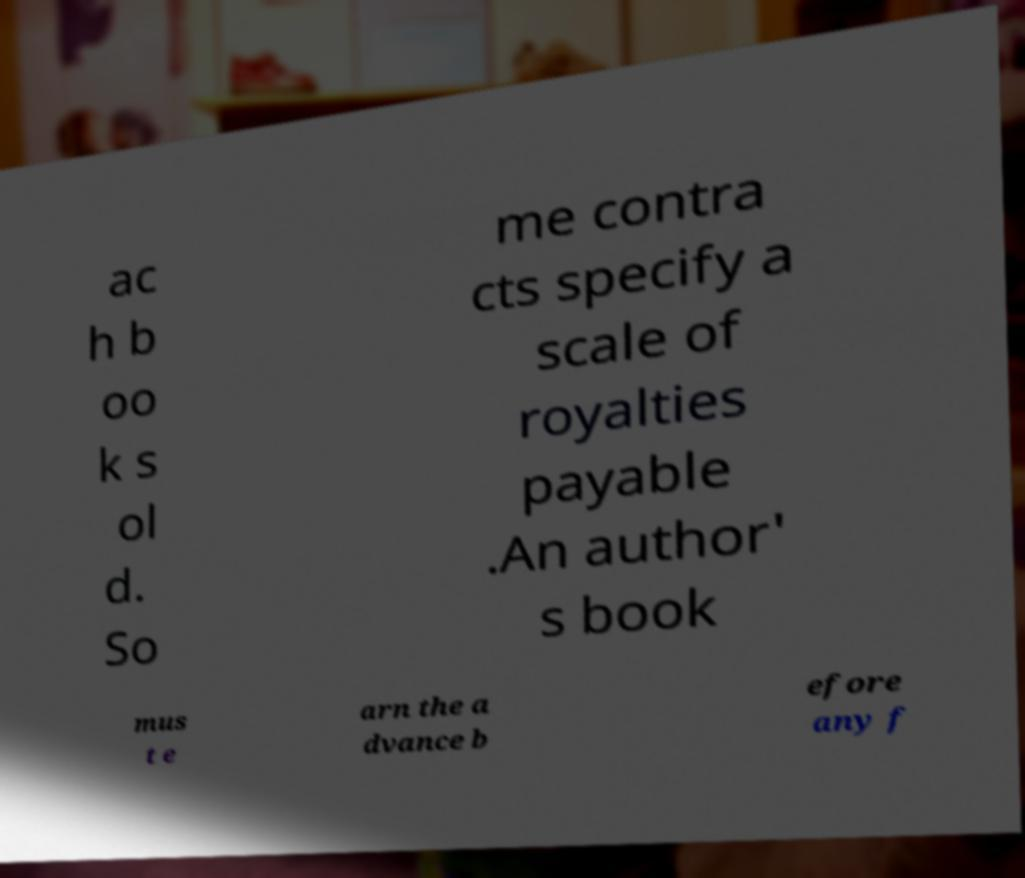There's text embedded in this image that I need extracted. Can you transcribe it verbatim? ac h b oo k s ol d. So me contra cts specify a scale of royalties payable .An author' s book mus t e arn the a dvance b efore any f 